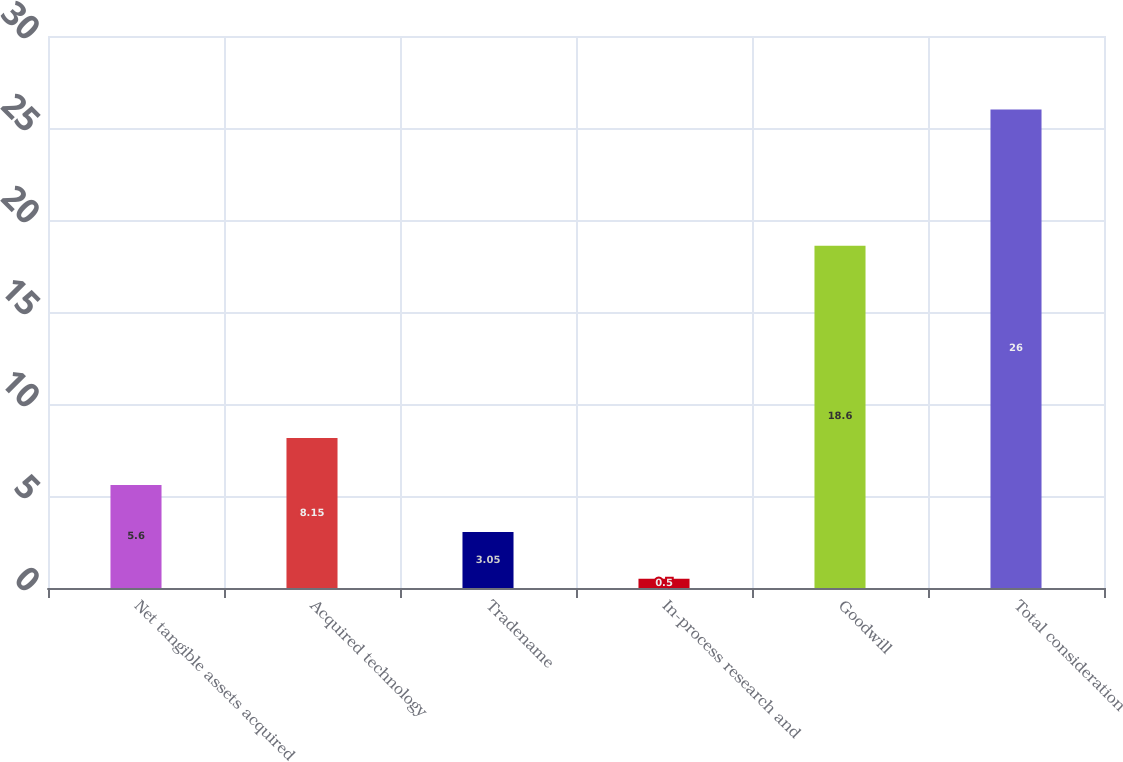<chart> <loc_0><loc_0><loc_500><loc_500><bar_chart><fcel>Net tangible assets acquired<fcel>Acquired technology<fcel>Tradename<fcel>In-process research and<fcel>Goodwill<fcel>Total consideration<nl><fcel>5.6<fcel>8.15<fcel>3.05<fcel>0.5<fcel>18.6<fcel>26<nl></chart> 